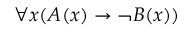Convert formula to latex. <formula><loc_0><loc_0><loc_500><loc_500>\forall x ( A ( x ) \rightarrow \neg B ( x ) )</formula> 